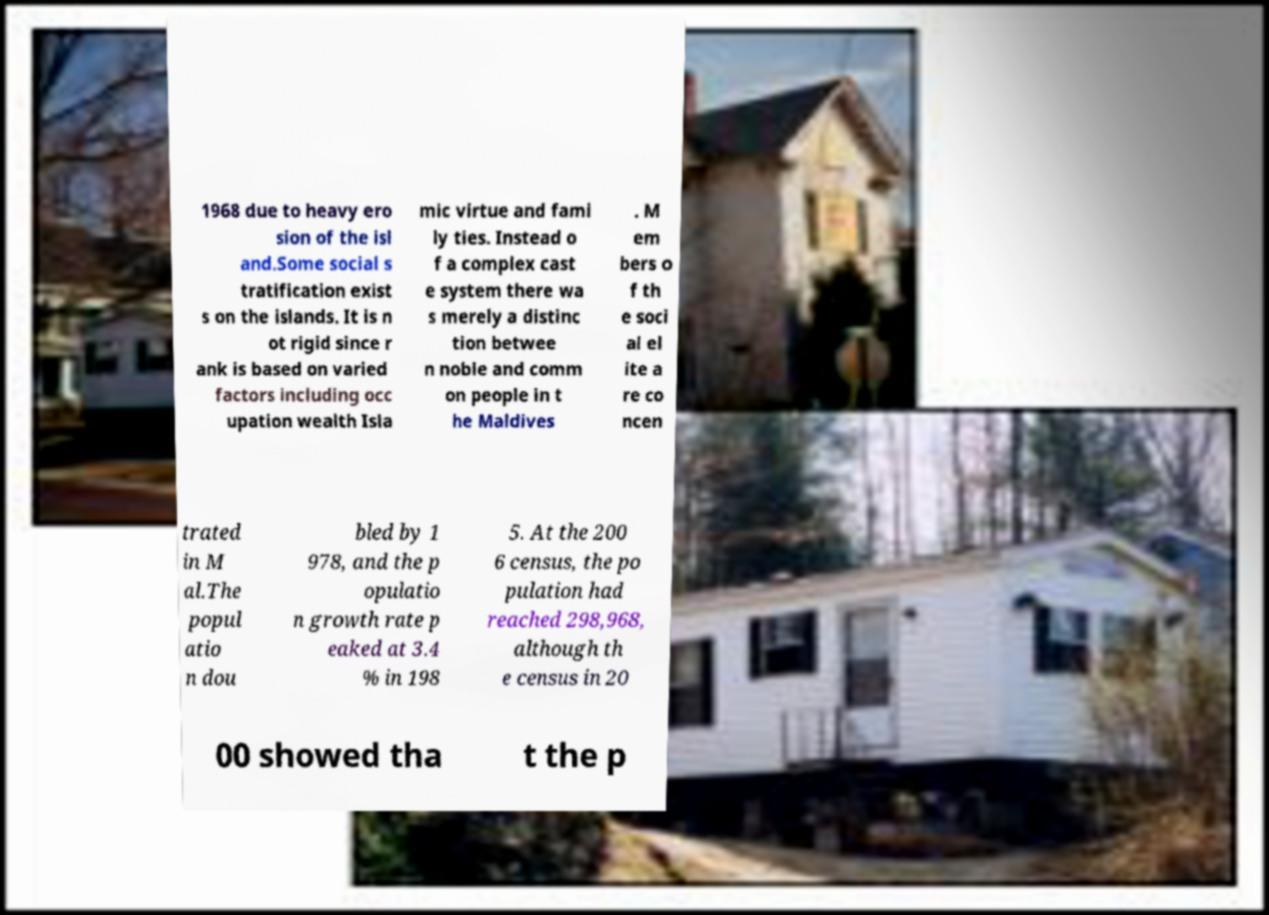Please identify and transcribe the text found in this image. 1968 due to heavy ero sion of the isl and.Some social s tratification exist s on the islands. It is n ot rigid since r ank is based on varied factors including occ upation wealth Isla mic virtue and fami ly ties. Instead o f a complex cast e system there wa s merely a distinc tion betwee n noble and comm on people in t he Maldives . M em bers o f th e soci al el ite a re co ncen trated in M al.The popul atio n dou bled by 1 978, and the p opulatio n growth rate p eaked at 3.4 % in 198 5. At the 200 6 census, the po pulation had reached 298,968, although th e census in 20 00 showed tha t the p 